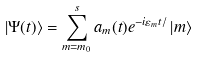<formula> <loc_0><loc_0><loc_500><loc_500>\left | \Psi ( t ) \right \rangle = \sum _ { m = m _ { 0 } } ^ { s } a _ { m } ( t ) e ^ { - i \varepsilon _ { m } t / } \left | m \right \rangle</formula> 